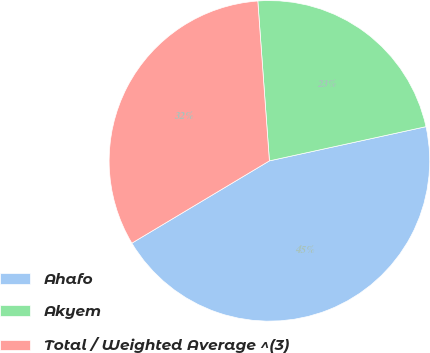Convert chart. <chart><loc_0><loc_0><loc_500><loc_500><pie_chart><fcel>Ahafo<fcel>Akyem<fcel>Total / Weighted Average ^(3)<nl><fcel>44.84%<fcel>22.73%<fcel>32.43%<nl></chart> 